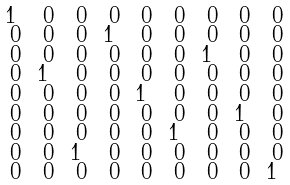Convert formula to latex. <formula><loc_0><loc_0><loc_500><loc_500>\begin{smallmatrix} 1 & \ 0 & \ 0 & \ 0 & \ 0 & \ 0 & \ 0 & \ 0 & \ 0 \\ \ 0 & \ 0 & \ 0 & 1 & \ 0 & \ 0 & \ 0 & \ 0 & \ 0 \\ \ 0 & \ 0 & \ 0 & \ 0 & \ 0 & \ 0 & 1 & \ 0 & \ 0 \\ \ 0 & 1 & \ 0 & \ 0 & \ 0 & \ 0 & \ 0 & \ 0 & \ 0 \\ \ 0 & \ 0 & \ 0 & \ 0 & 1 & \ 0 & \ 0 & \ 0 & \ 0 \\ \ 0 & \ 0 & \ 0 & \ 0 & \ 0 & \ 0 & \ 0 & 1 & \ 0 \\ \ 0 & \ 0 & \ 0 & \ 0 & \ 0 & 1 & \ 0 & \ 0 & \ 0 \\ \ 0 & \ 0 & 1 & \ 0 & \ 0 & \ 0 & \ 0 & \ 0 & \ 0 \\ \ 0 & \ 0 & \ 0 & \ 0 & \ 0 & \ 0 & \ 0 & \ 0 & 1 \end{smallmatrix}</formula> 